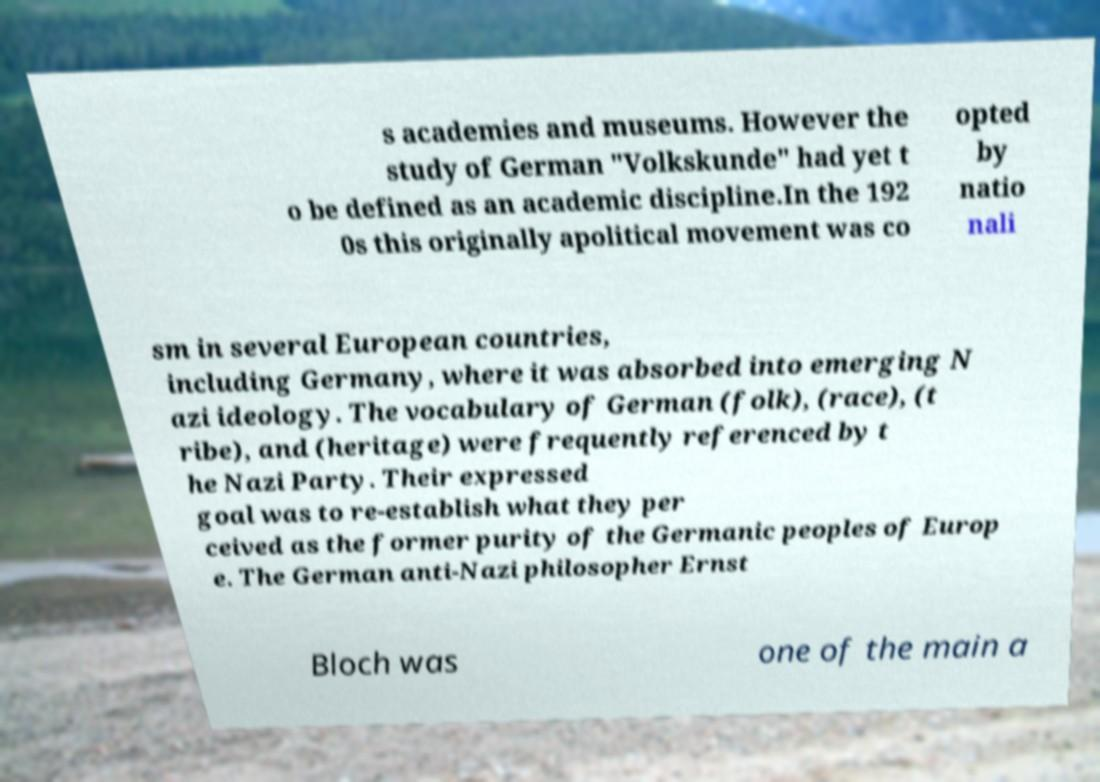Could you assist in decoding the text presented in this image and type it out clearly? s academies and museums. However the study of German "Volkskunde" had yet t o be defined as an academic discipline.In the 192 0s this originally apolitical movement was co opted by natio nali sm in several European countries, including Germany, where it was absorbed into emerging N azi ideology. The vocabulary of German (folk), (race), (t ribe), and (heritage) were frequently referenced by t he Nazi Party. Their expressed goal was to re-establish what they per ceived as the former purity of the Germanic peoples of Europ e. The German anti-Nazi philosopher Ernst Bloch was one of the main a 